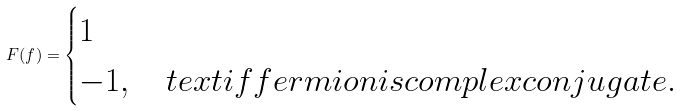<formula> <loc_0><loc_0><loc_500><loc_500>F ( f ) = \begin{cases} 1 \\ - 1 , \ \ \ t e x t { i f f e r m i o n i s c o m p l e x c o n j u g a t e } . \end{cases}</formula> 